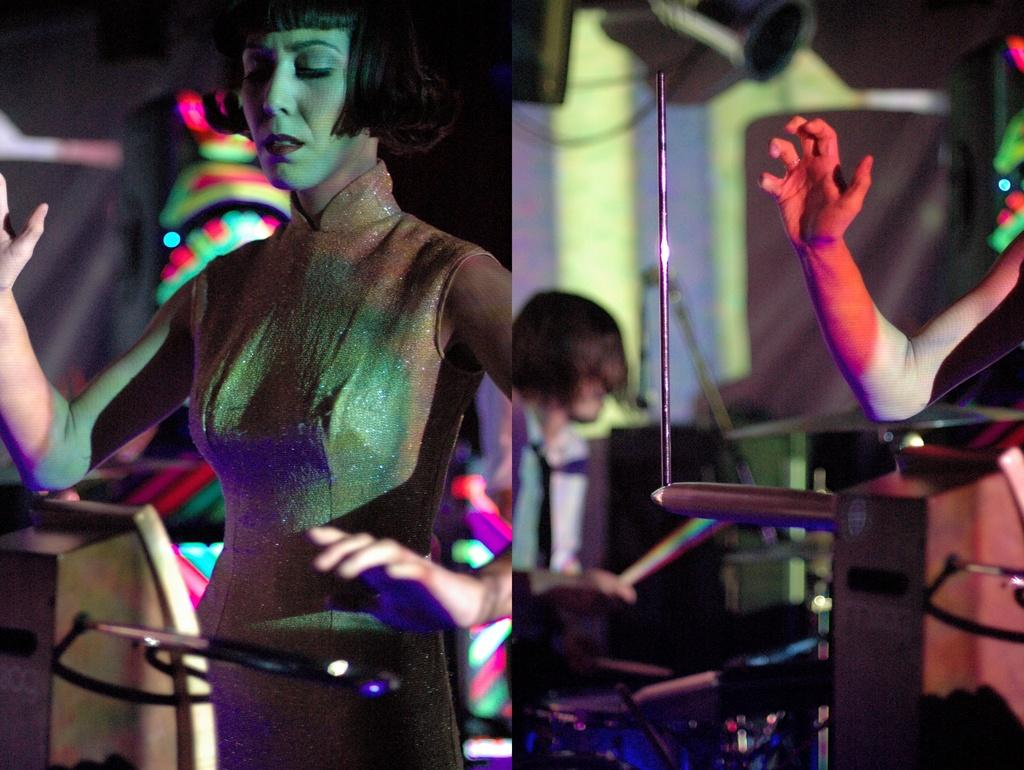What is the woman doing in the image? The woman is standing in front of an object in the image. Can you describe the position of the person in the image? There is a person sitting on a chair in the image. What can be seen on the left side of the image? There is a hand on the left side of the image. What flavor of fear does the crow exhibit in the image? There is no crow present in the image, and therefore no fear or flavor can be attributed to it. 